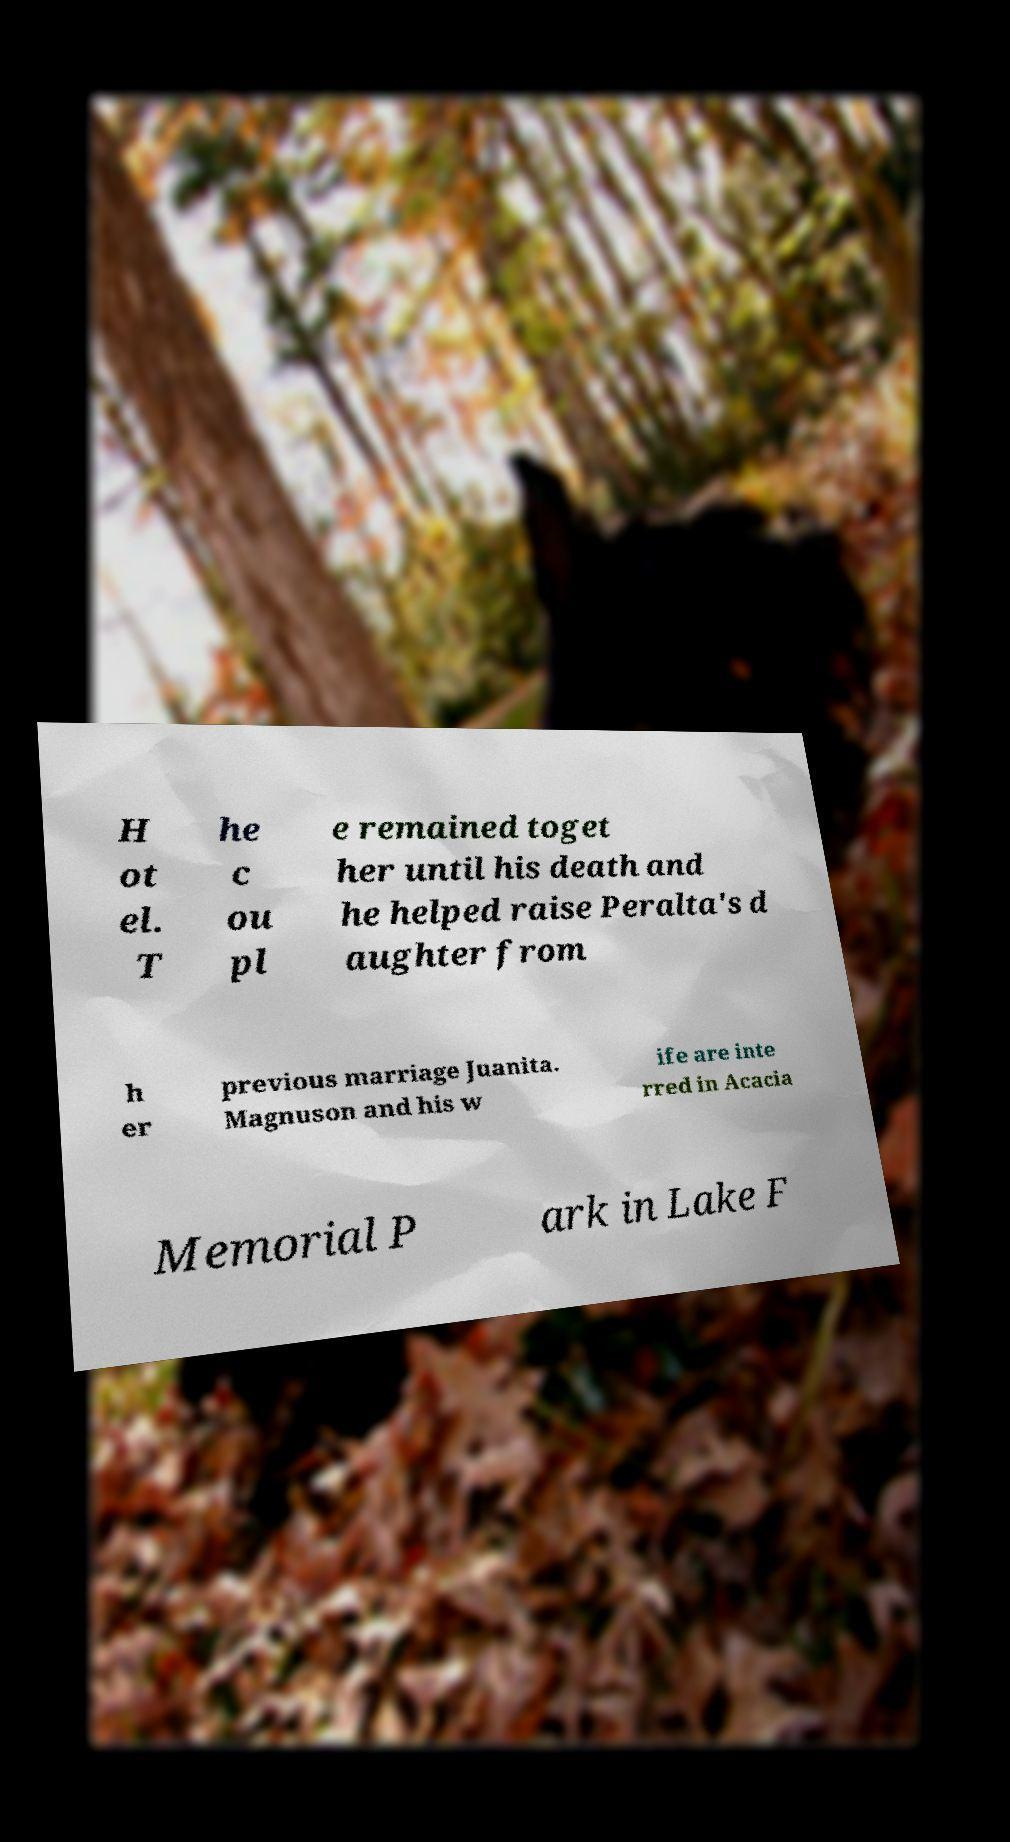There's text embedded in this image that I need extracted. Can you transcribe it verbatim? H ot el. T he c ou pl e remained toget her until his death and he helped raise Peralta's d aughter from h er previous marriage Juanita. Magnuson and his w ife are inte rred in Acacia Memorial P ark in Lake F 